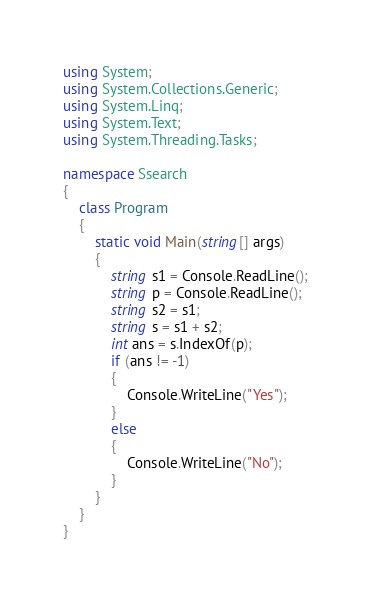Convert code to text. <code><loc_0><loc_0><loc_500><loc_500><_C#_>using System;
using System.Collections.Generic;
using System.Linq;
using System.Text;
using System.Threading.Tasks;

namespace Ssearch
{
    class Program
    {
        static void Main(string[] args)
        {
            string s1 = Console.ReadLine();
            string p = Console.ReadLine();
            string s2 = s1;
            string s = s1 + s2;
            int ans = s.IndexOf(p);
            if (ans != -1)
            {
                Console.WriteLine("Yes");
            }
            else
            {
                Console.WriteLine("No");
            }
        }
    }
}</code> 